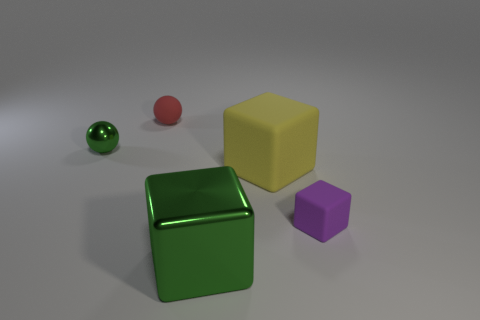How would you describe the lighting in this scene? The lighting appears to be soft and diffuse, possibly simulating an overcast day or indoor lighting with a single source, as evidenced by the soft shadows beneath the objects. 